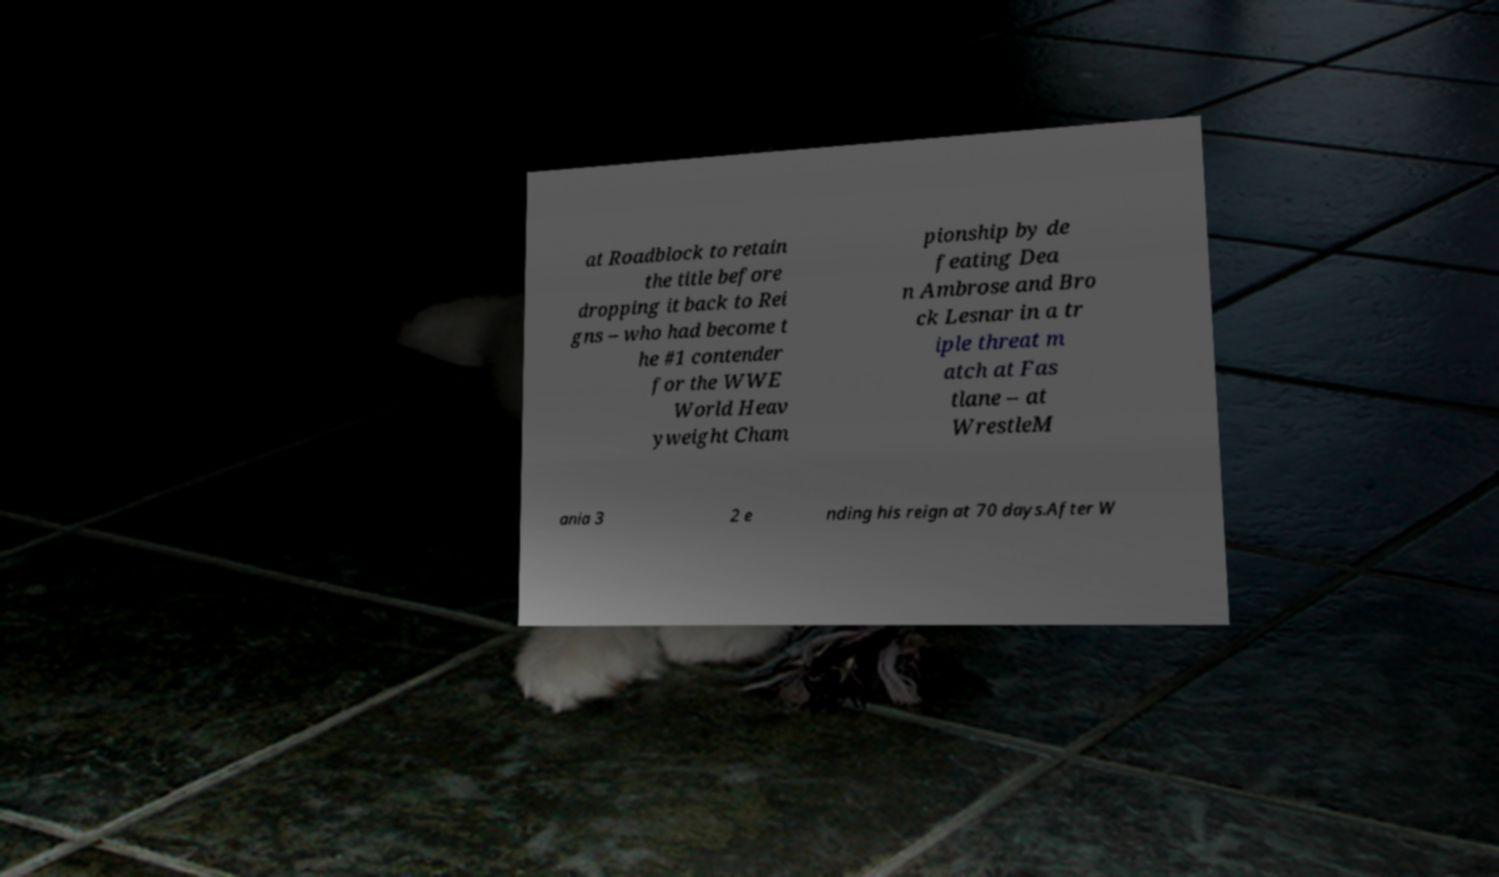Could you assist in decoding the text presented in this image and type it out clearly? at Roadblock to retain the title before dropping it back to Rei gns – who had become t he #1 contender for the WWE World Heav yweight Cham pionship by de feating Dea n Ambrose and Bro ck Lesnar in a tr iple threat m atch at Fas tlane – at WrestleM ania 3 2 e nding his reign at 70 days.After W 